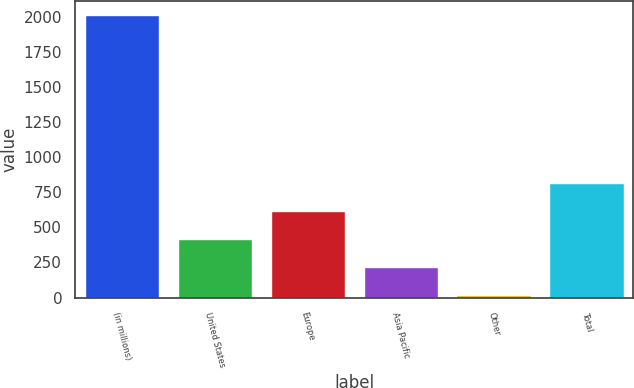<chart> <loc_0><loc_0><loc_500><loc_500><bar_chart><fcel>(in millions)<fcel>United States<fcel>Europe<fcel>Asia Pacific<fcel>Other<fcel>Total<nl><fcel>2010<fcel>416.4<fcel>615.6<fcel>217.2<fcel>18<fcel>814.8<nl></chart> 